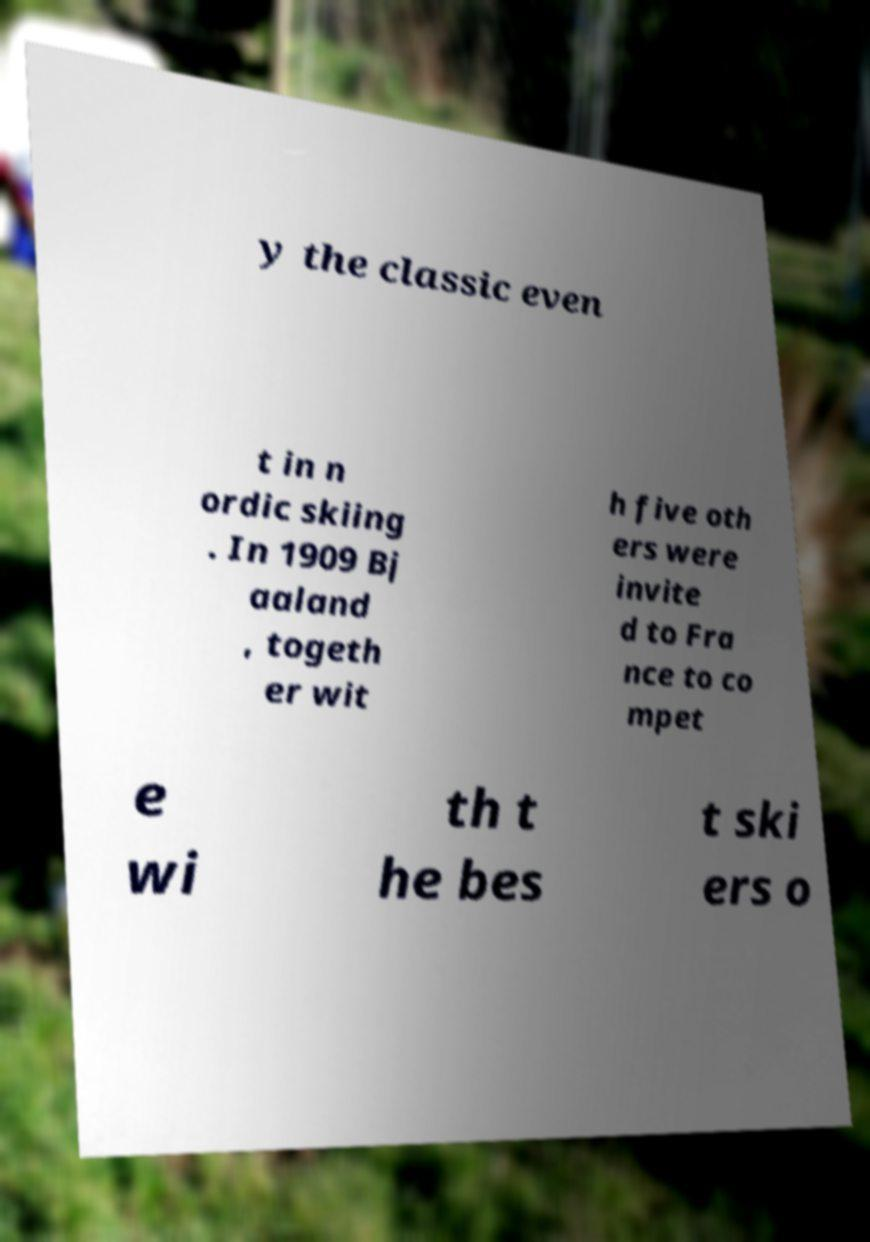Could you extract and type out the text from this image? y the classic even t in n ordic skiing . In 1909 Bj aaland , togeth er wit h five oth ers were invite d to Fra nce to co mpet e wi th t he bes t ski ers o 